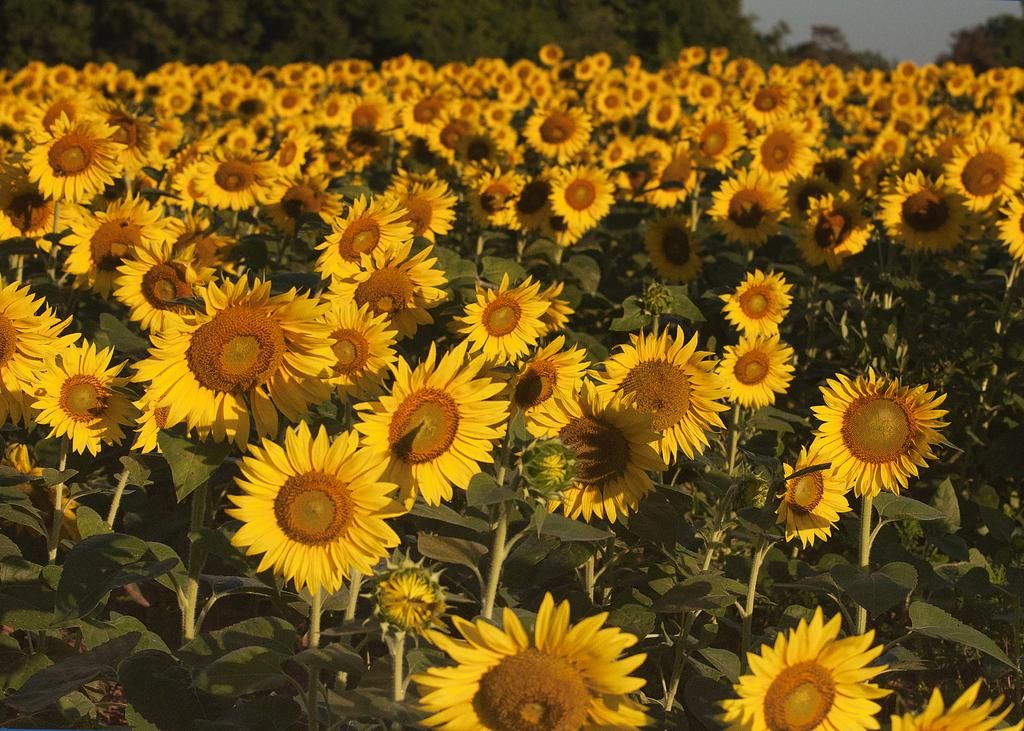What type of flowers are in the image? There are sunflowers in the image. What color are the sunflowers? The sunflowers are in yellow color. What other color is present in the image besides yellow? There are green leaves in the image. What can be seen in the background of the image? There are trees visible in the background of the image. What type of pet can be seen playing with a ball in the image? There is no pet or ball present in the image; it features sunflowers and green leaves. 